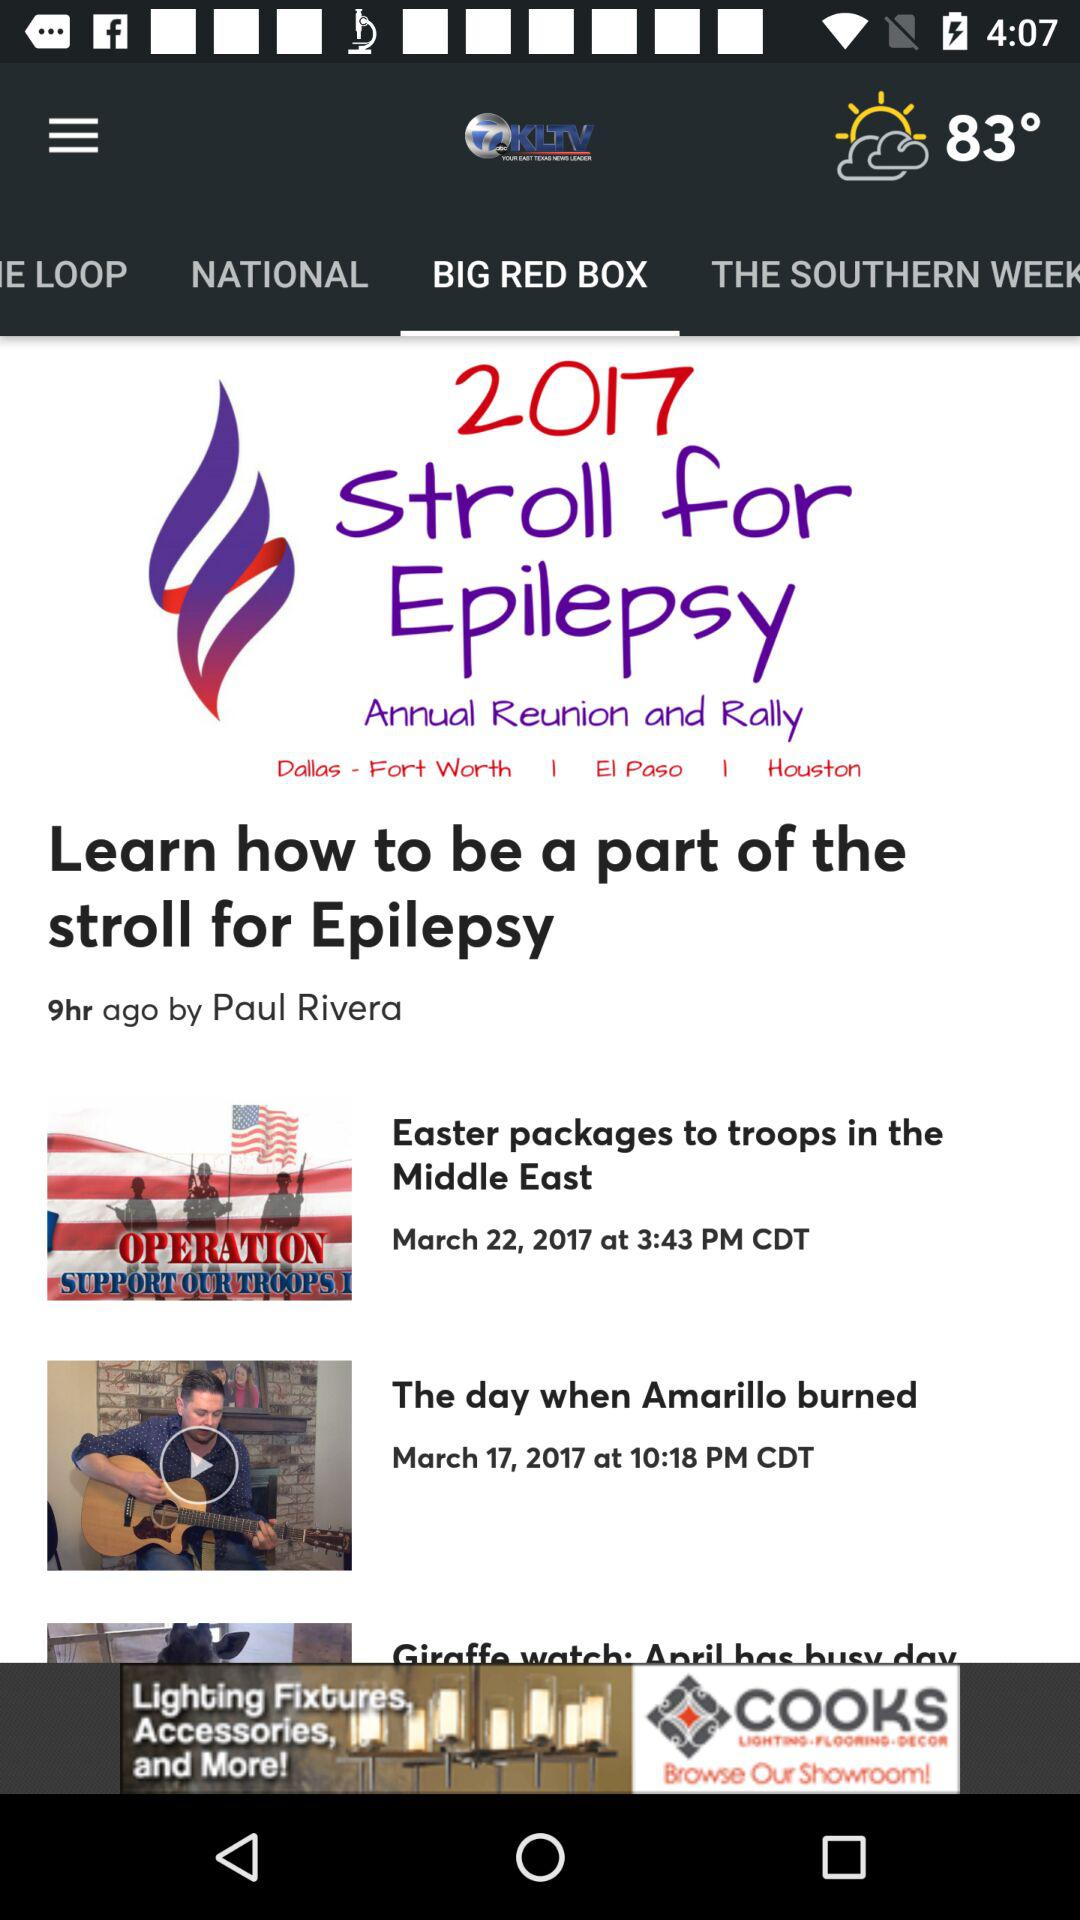When was the video of "The day when Amarillo burned" posted? The video was posted on March 17, 2017 at 10:18 PM. 